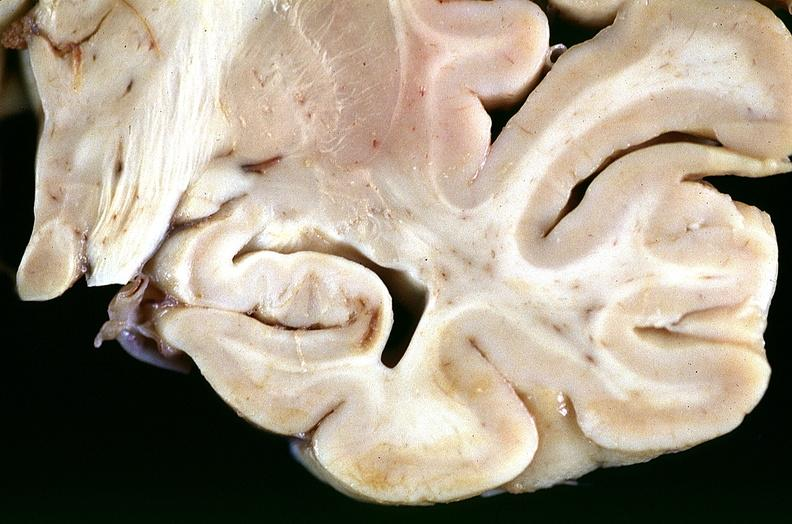does this image show brain, infarcts, hypotension?
Answer the question using a single word or phrase. Yes 